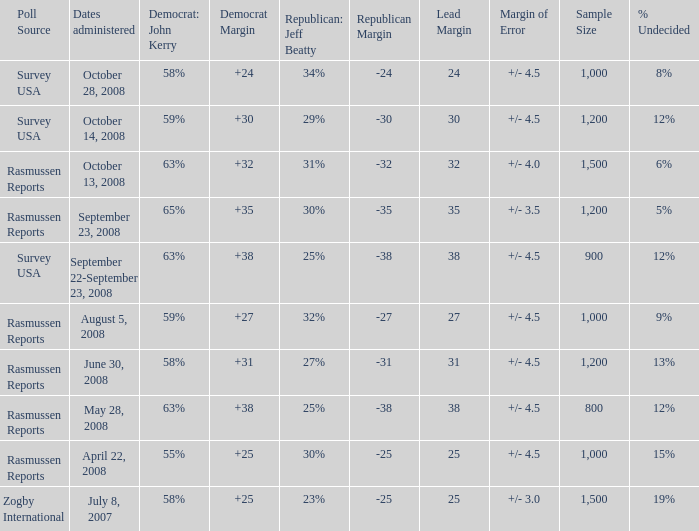What percent is the lead margin of 25 that Republican: Jeff Beatty has according to poll source Rasmussen Reports? 30%. 